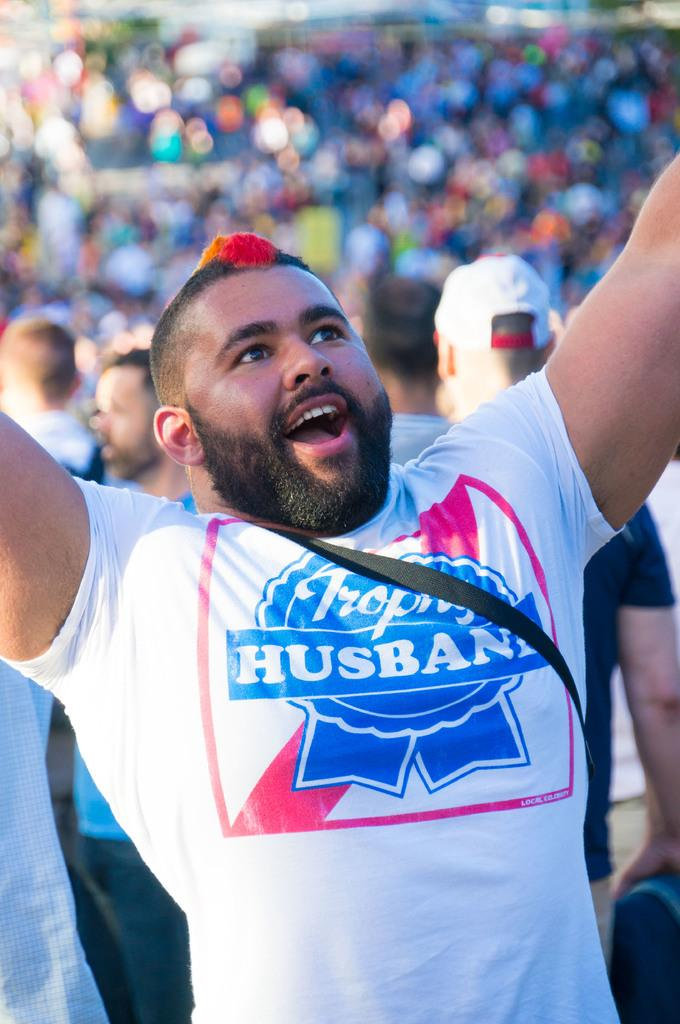Who is present in the image? There is a person in the image. What is the person doing in the image? The person is looking upwards and smiling. What can be observed about the background of the image? The background of the image is blurred. Are there any other people in the image besides the main person? Yes, there are other people in the image. What type of bell can be heard ringing in the image? There is no bell present or audible in the image. 